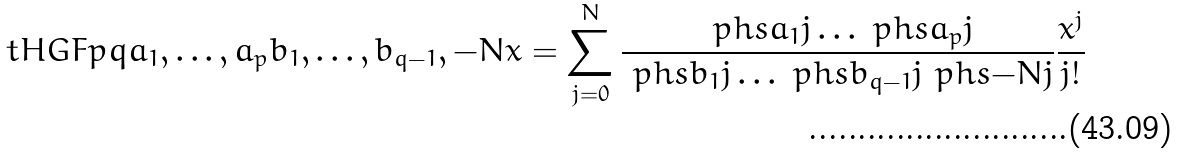Convert formula to latex. <formula><loc_0><loc_0><loc_500><loc_500>\ t H G F p q { a _ { 1 } , \dots , a _ { p } } { b _ { 1 } , \dots , b _ { q - 1 } , - N } x = \sum _ { j = 0 } ^ { N } \frac { \ p h s { a _ { 1 } } j \dots \ p h s { a _ { p } } j } { \ p h s { b _ { 1 } } j \dots \ p h s { b _ { q - 1 } } j \ p h s { - N } j } \frac { x ^ { j } } { j ! }</formula> 